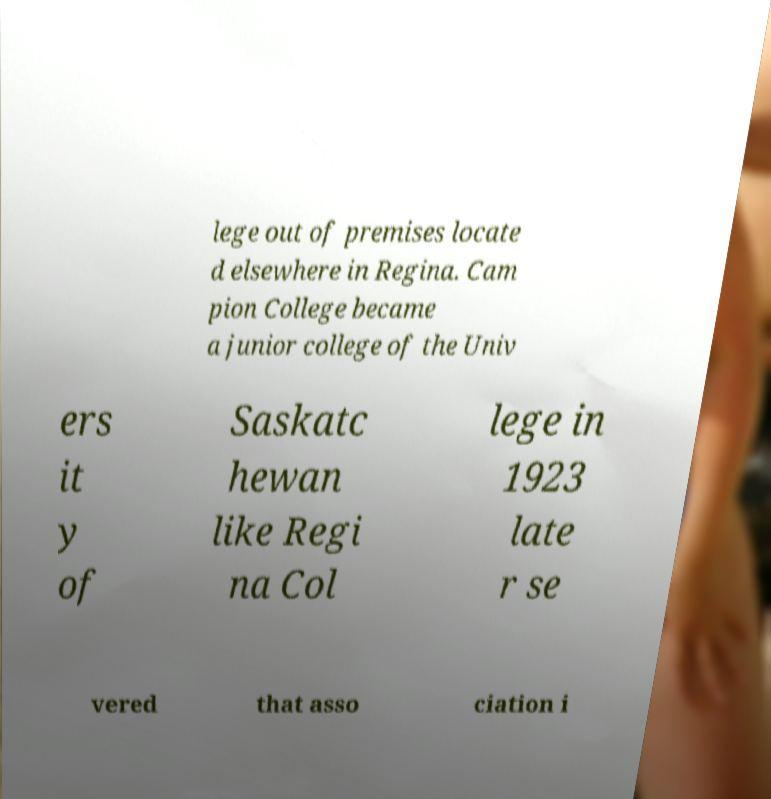For documentation purposes, I need the text within this image transcribed. Could you provide that? lege out of premises locate d elsewhere in Regina. Cam pion College became a junior college of the Univ ers it y of Saskatc hewan like Regi na Col lege in 1923 late r se vered that asso ciation i 